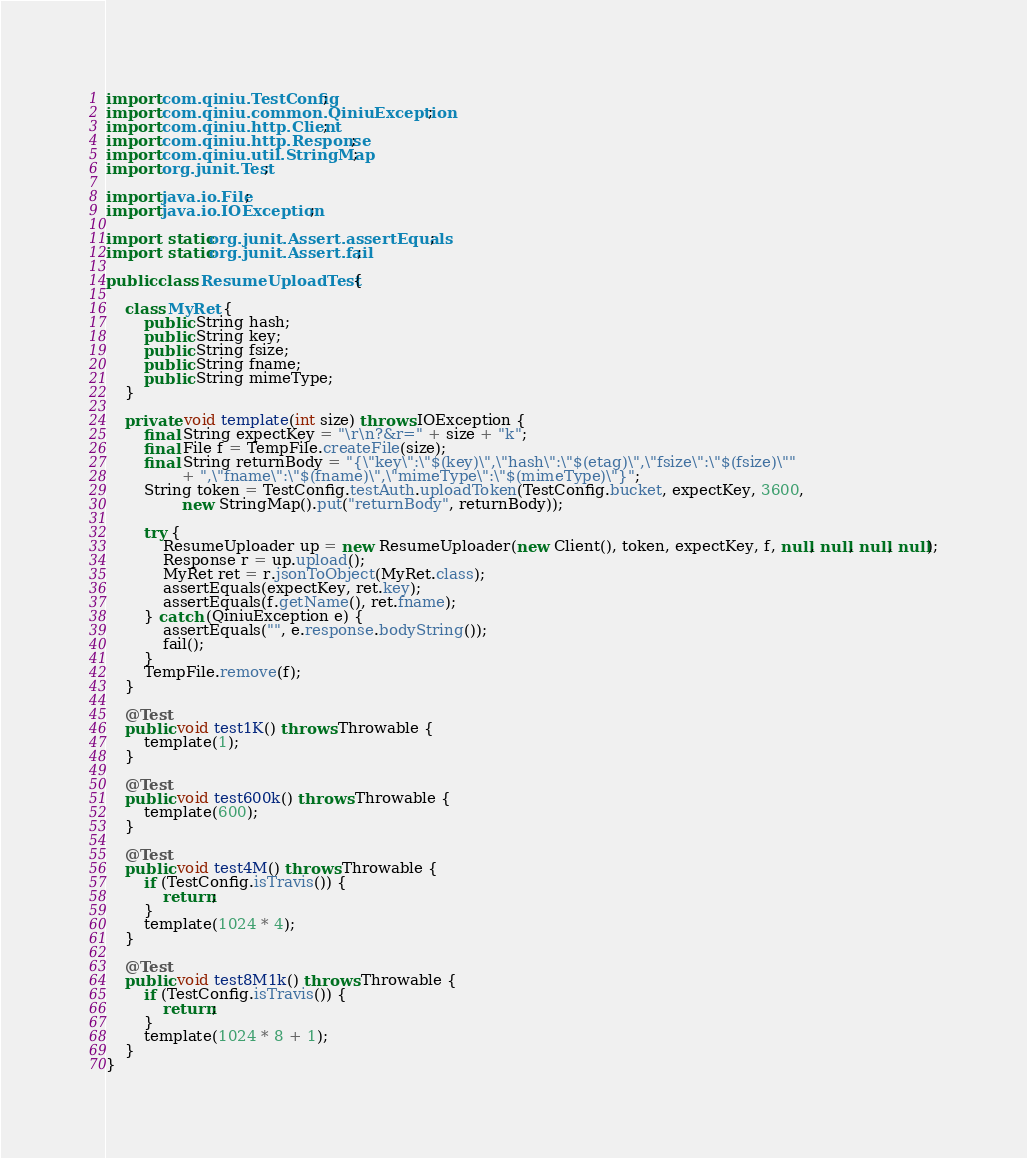<code> <loc_0><loc_0><loc_500><loc_500><_Java_>import com.qiniu.TestConfig;
import com.qiniu.common.QiniuException;
import com.qiniu.http.Client;
import com.qiniu.http.Response;
import com.qiniu.util.StringMap;
import org.junit.Test;

import java.io.File;
import java.io.IOException;

import static org.junit.Assert.assertEquals;
import static org.junit.Assert.fail;

public class ResumeUploadTest {

    class MyRet {
        public String hash;
        public String key;
        public String fsize;
        public String fname;
        public String mimeType;
    }

    private void template(int size) throws IOException {
        final String expectKey = "\r\n?&r=" + size + "k";
        final File f = TempFile.createFile(size);
        final String returnBody = "{\"key\":\"$(key)\",\"hash\":\"$(etag)\",\"fsize\":\"$(fsize)\""
                + ",\"fname\":\"$(fname)\",\"mimeType\":\"$(mimeType)\"}";
        String token = TestConfig.testAuth.uploadToken(TestConfig.bucket, expectKey, 3600,
                new StringMap().put("returnBody", returnBody));

        try {
            ResumeUploader up = new ResumeUploader(new Client(), token, expectKey, f, null, null, null, null);
            Response r = up.upload();
            MyRet ret = r.jsonToObject(MyRet.class);
            assertEquals(expectKey, ret.key);
            assertEquals(f.getName(), ret.fname);
        } catch (QiniuException e) {
            assertEquals("", e.response.bodyString());
            fail();
        }
        TempFile.remove(f);
    }

    @Test
    public void test1K() throws Throwable {
        template(1);
    }

    @Test
    public void test600k() throws Throwable {
        template(600);
    }

    @Test
    public void test4M() throws Throwable {
        if (TestConfig.isTravis()) {
            return;
        }
        template(1024 * 4);
    }

    @Test
    public void test8M1k() throws Throwable {
        if (TestConfig.isTravis()) {
            return;
        }
        template(1024 * 8 + 1);
    }
}
</code> 